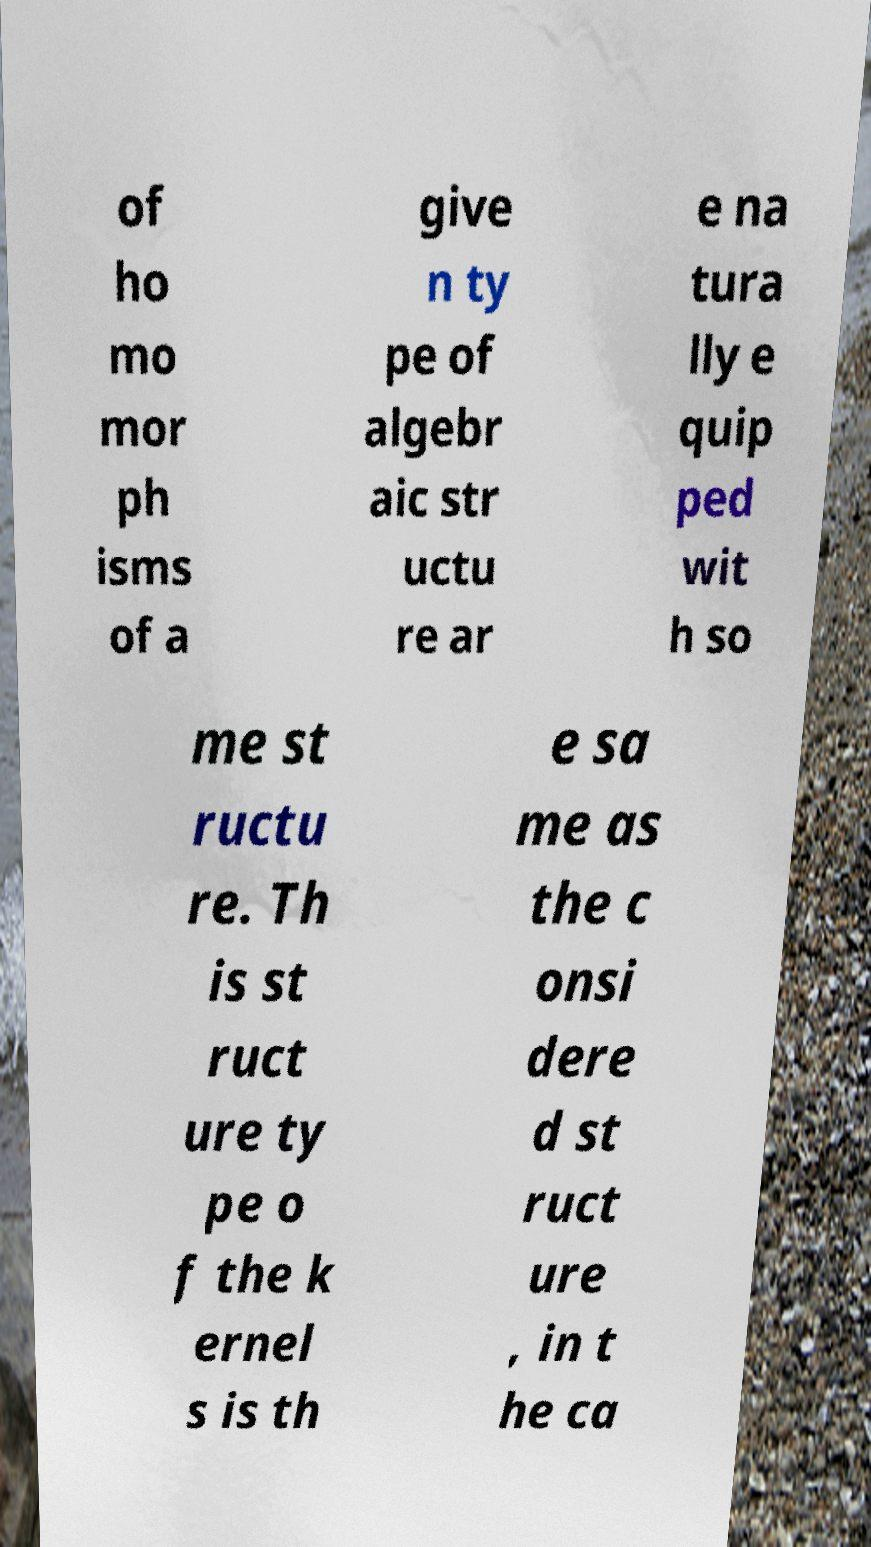There's text embedded in this image that I need extracted. Can you transcribe it verbatim? of ho mo mor ph isms of a give n ty pe of algebr aic str uctu re ar e na tura lly e quip ped wit h so me st ructu re. Th is st ruct ure ty pe o f the k ernel s is th e sa me as the c onsi dere d st ruct ure , in t he ca 